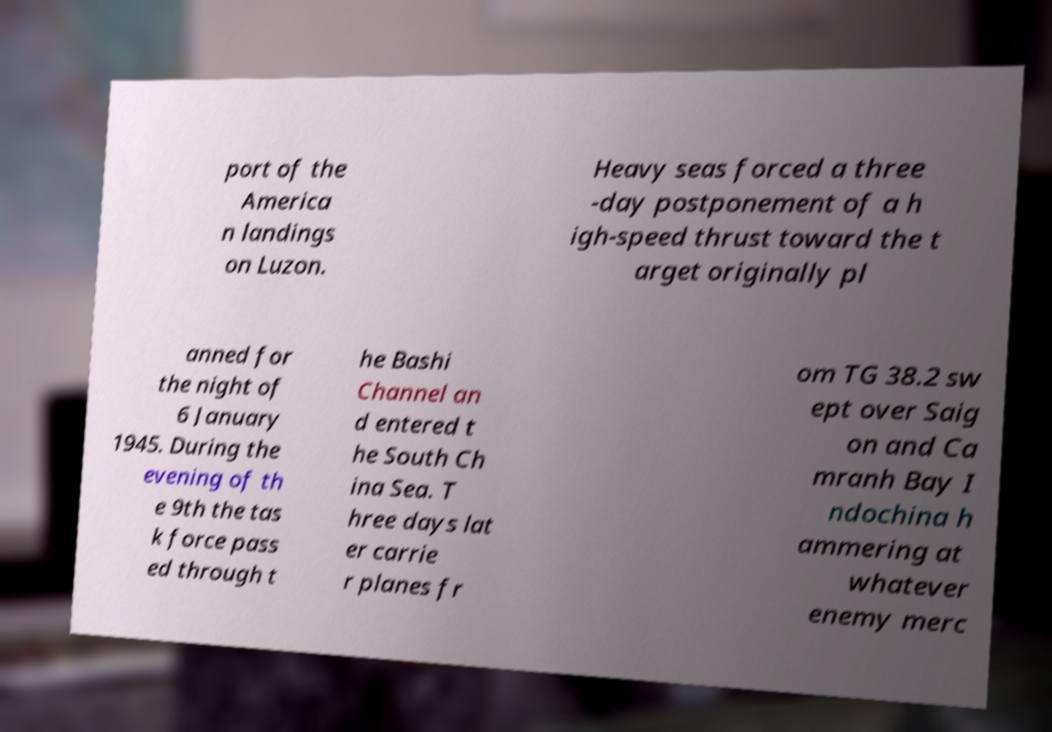Can you accurately transcribe the text from the provided image for me? port of the America n landings on Luzon. Heavy seas forced a three -day postponement of a h igh-speed thrust toward the t arget originally pl anned for the night of 6 January 1945. During the evening of th e 9th the tas k force pass ed through t he Bashi Channel an d entered t he South Ch ina Sea. T hree days lat er carrie r planes fr om TG 38.2 sw ept over Saig on and Ca mranh Bay I ndochina h ammering at whatever enemy merc 